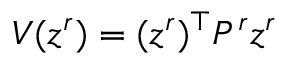Convert formula to latex. <formula><loc_0><loc_0><loc_500><loc_500>V ( z ^ { r } ) = ( z ^ { r } ) ^ { \top } P ^ { r } z ^ { r }</formula> 